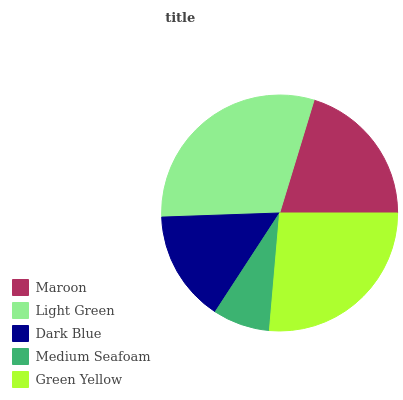Is Medium Seafoam the minimum?
Answer yes or no. Yes. Is Light Green the maximum?
Answer yes or no. Yes. Is Dark Blue the minimum?
Answer yes or no. No. Is Dark Blue the maximum?
Answer yes or no. No. Is Light Green greater than Dark Blue?
Answer yes or no. Yes. Is Dark Blue less than Light Green?
Answer yes or no. Yes. Is Dark Blue greater than Light Green?
Answer yes or no. No. Is Light Green less than Dark Blue?
Answer yes or no. No. Is Maroon the high median?
Answer yes or no. Yes. Is Maroon the low median?
Answer yes or no. Yes. Is Light Green the high median?
Answer yes or no. No. Is Dark Blue the low median?
Answer yes or no. No. 